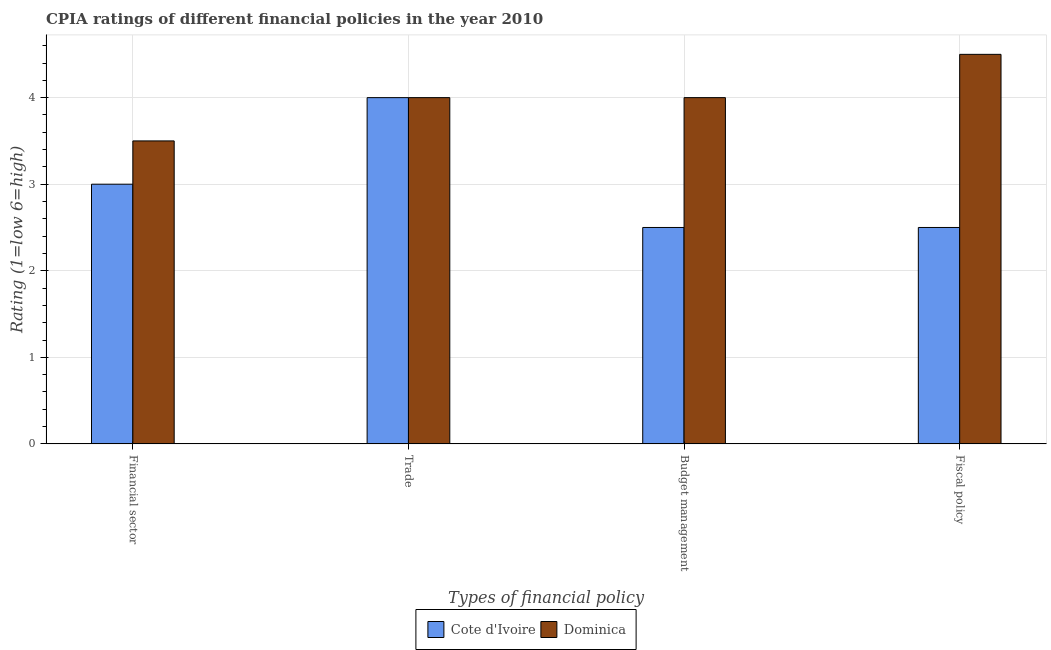How many different coloured bars are there?
Ensure brevity in your answer.  2. How many groups of bars are there?
Give a very brief answer. 4. How many bars are there on the 3rd tick from the left?
Keep it short and to the point. 2. How many bars are there on the 4th tick from the right?
Provide a short and direct response. 2. What is the label of the 1st group of bars from the left?
Your answer should be compact. Financial sector. Across all countries, what is the maximum cpia rating of financial sector?
Make the answer very short. 3.5. Across all countries, what is the minimum cpia rating of fiscal policy?
Provide a short and direct response. 2.5. In which country was the cpia rating of fiscal policy maximum?
Offer a very short reply. Dominica. In which country was the cpia rating of financial sector minimum?
Ensure brevity in your answer.  Cote d'Ivoire. What is the total cpia rating of budget management in the graph?
Offer a terse response. 6.5. What is the difference between the cpia rating of budget management in Cote d'Ivoire and that in Dominica?
Provide a succinct answer. -1.5. What is the average cpia rating of financial sector per country?
Keep it short and to the point. 3.25. What is the ratio of the cpia rating of fiscal policy in Dominica to that in Cote d'Ivoire?
Give a very brief answer. 1.8. What is the difference between the highest and the lowest cpia rating of trade?
Your answer should be very brief. 0. In how many countries, is the cpia rating of trade greater than the average cpia rating of trade taken over all countries?
Ensure brevity in your answer.  0. What does the 2nd bar from the left in Budget management represents?
Provide a short and direct response. Dominica. What does the 2nd bar from the right in Budget management represents?
Ensure brevity in your answer.  Cote d'Ivoire. Is it the case that in every country, the sum of the cpia rating of financial sector and cpia rating of trade is greater than the cpia rating of budget management?
Your answer should be very brief. Yes. How many bars are there?
Your answer should be compact. 8. Are all the bars in the graph horizontal?
Ensure brevity in your answer.  No. How many countries are there in the graph?
Offer a very short reply. 2. What is the difference between two consecutive major ticks on the Y-axis?
Ensure brevity in your answer.  1. Are the values on the major ticks of Y-axis written in scientific E-notation?
Your answer should be compact. No. Does the graph contain grids?
Provide a succinct answer. Yes. How many legend labels are there?
Your answer should be very brief. 2. What is the title of the graph?
Offer a very short reply. CPIA ratings of different financial policies in the year 2010. Does "Low & middle income" appear as one of the legend labels in the graph?
Give a very brief answer. No. What is the label or title of the X-axis?
Keep it short and to the point. Types of financial policy. What is the label or title of the Y-axis?
Make the answer very short. Rating (1=low 6=high). What is the Rating (1=low 6=high) of Cote d'Ivoire in Financial sector?
Ensure brevity in your answer.  3. What is the Rating (1=low 6=high) of Cote d'Ivoire in Trade?
Provide a short and direct response. 4. What is the Rating (1=low 6=high) of Dominica in Trade?
Ensure brevity in your answer.  4. What is the Rating (1=low 6=high) of Cote d'Ivoire in Budget management?
Your answer should be very brief. 2.5. What is the Rating (1=low 6=high) in Dominica in Budget management?
Make the answer very short. 4. What is the Rating (1=low 6=high) in Cote d'Ivoire in Fiscal policy?
Keep it short and to the point. 2.5. What is the Rating (1=low 6=high) of Dominica in Fiscal policy?
Your response must be concise. 4.5. Across all Types of financial policy, what is the minimum Rating (1=low 6=high) in Cote d'Ivoire?
Give a very brief answer. 2.5. What is the difference between the Rating (1=low 6=high) of Cote d'Ivoire in Financial sector and that in Trade?
Provide a short and direct response. -1. What is the difference between the Rating (1=low 6=high) in Cote d'Ivoire in Financial sector and that in Budget management?
Your response must be concise. 0.5. What is the difference between the Rating (1=low 6=high) in Dominica in Trade and that in Budget management?
Offer a very short reply. 0. What is the difference between the Rating (1=low 6=high) of Cote d'Ivoire in Trade and that in Fiscal policy?
Ensure brevity in your answer.  1.5. What is the difference between the Rating (1=low 6=high) in Cote d'Ivoire in Budget management and that in Fiscal policy?
Ensure brevity in your answer.  0. What is the difference between the Rating (1=low 6=high) in Dominica in Budget management and that in Fiscal policy?
Offer a terse response. -0.5. What is the difference between the Rating (1=low 6=high) of Cote d'Ivoire in Financial sector and the Rating (1=low 6=high) of Dominica in Trade?
Give a very brief answer. -1. What is the difference between the Rating (1=low 6=high) in Cote d'Ivoire and Rating (1=low 6=high) in Dominica in Financial sector?
Ensure brevity in your answer.  -0.5. What is the difference between the Rating (1=low 6=high) in Cote d'Ivoire and Rating (1=low 6=high) in Dominica in Budget management?
Offer a very short reply. -1.5. What is the ratio of the Rating (1=low 6=high) of Dominica in Financial sector to that in Trade?
Your answer should be very brief. 0.88. What is the ratio of the Rating (1=low 6=high) in Dominica in Financial sector to that in Budget management?
Give a very brief answer. 0.88. What is the ratio of the Rating (1=low 6=high) of Cote d'Ivoire in Financial sector to that in Fiscal policy?
Your answer should be compact. 1.2. What is the ratio of the Rating (1=low 6=high) of Dominica in Financial sector to that in Fiscal policy?
Provide a succinct answer. 0.78. What is the ratio of the Rating (1=low 6=high) in Cote d'Ivoire in Trade to that in Budget management?
Offer a terse response. 1.6. What is the ratio of the Rating (1=low 6=high) in Dominica in Trade to that in Fiscal policy?
Make the answer very short. 0.89. What is the ratio of the Rating (1=low 6=high) of Cote d'Ivoire in Budget management to that in Fiscal policy?
Offer a terse response. 1. What is the difference between the highest and the second highest Rating (1=low 6=high) in Dominica?
Provide a short and direct response. 0.5. What is the difference between the highest and the lowest Rating (1=low 6=high) in Cote d'Ivoire?
Your answer should be compact. 1.5. 